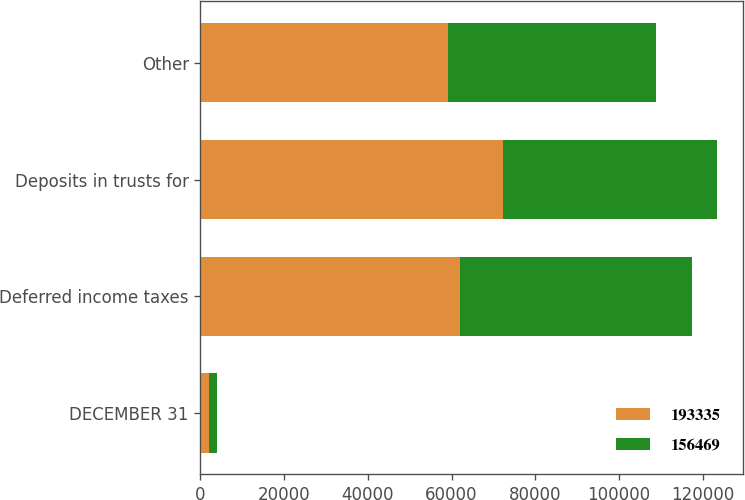Convert chart. <chart><loc_0><loc_0><loc_500><loc_500><stacked_bar_chart><ecel><fcel>DECEMBER 31<fcel>Deferred income taxes<fcel>Deposits in trusts for<fcel>Other<nl><fcel>193335<fcel>2008<fcel>61955<fcel>72295<fcel>59085<nl><fcel>156469<fcel>2007<fcel>55522<fcel>51179<fcel>49768<nl></chart> 